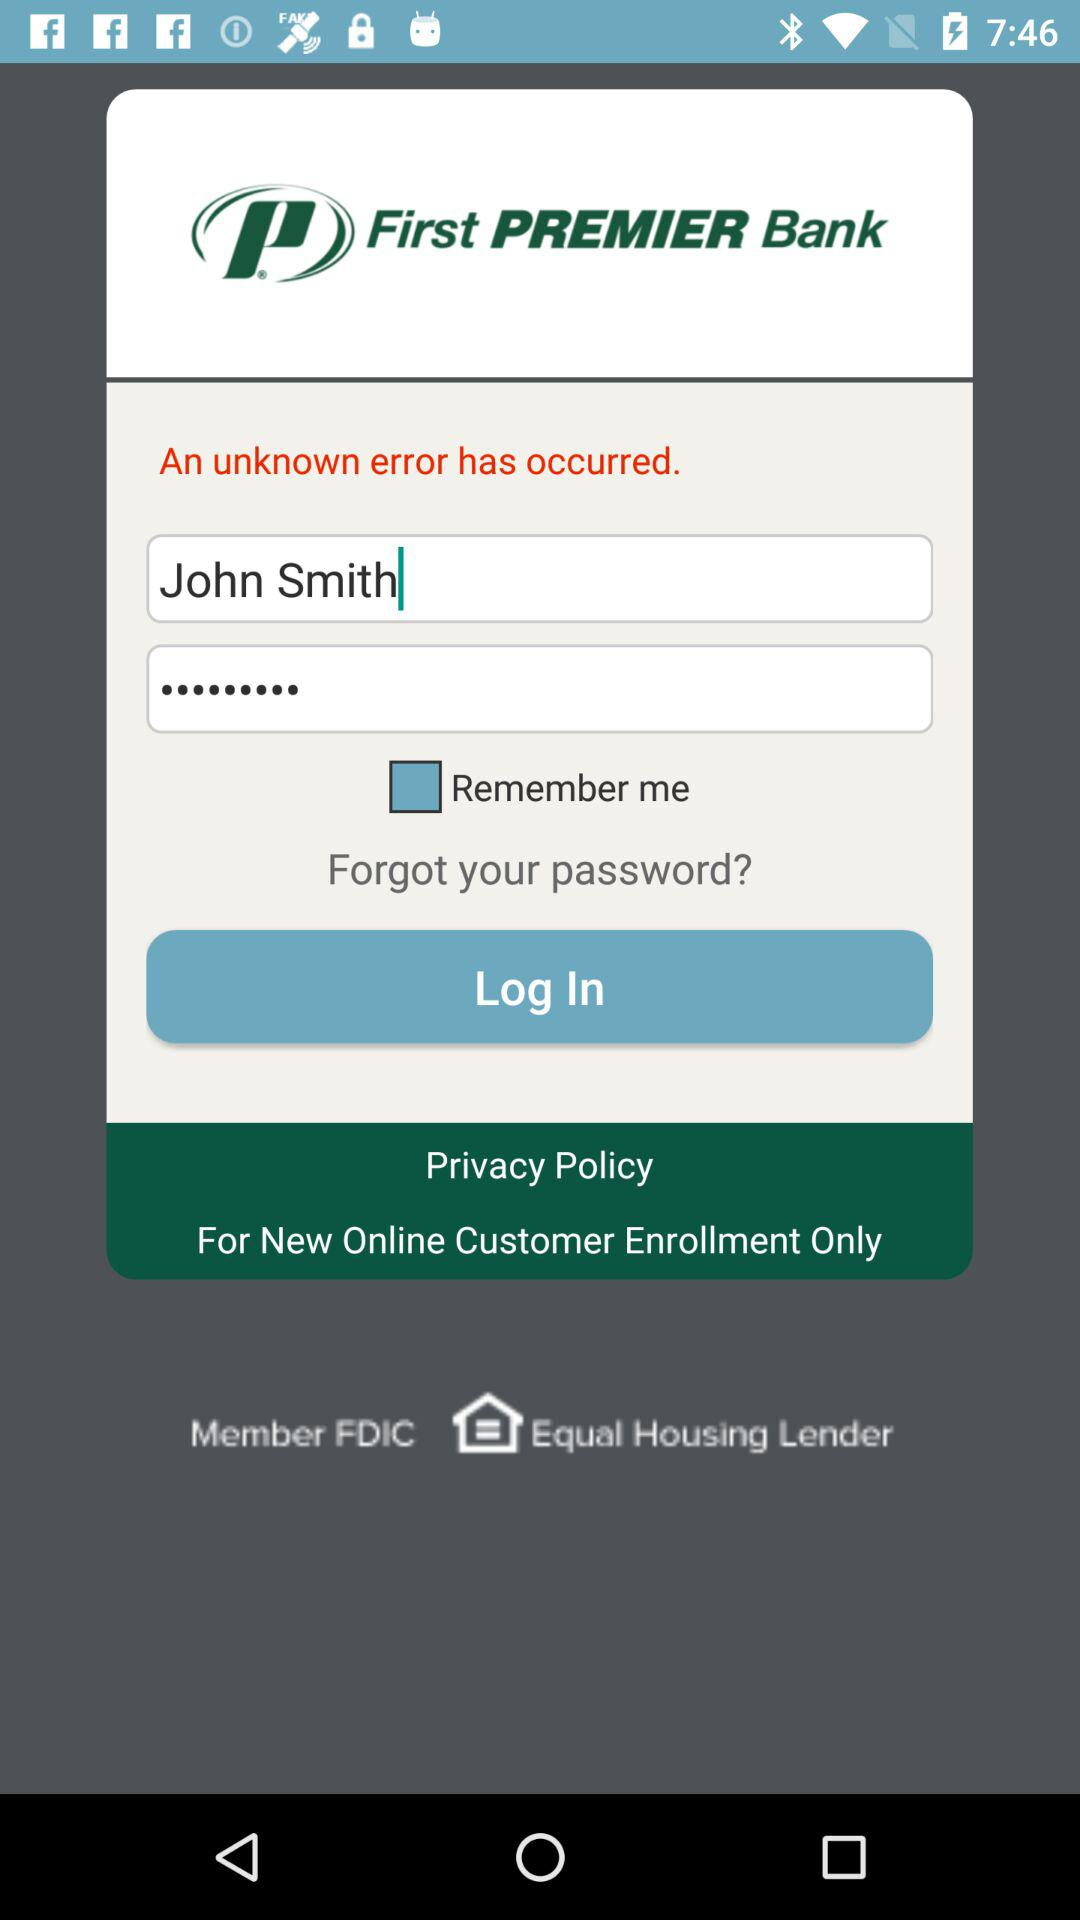What is the app name? The app name is "First PREMIER Bank". 